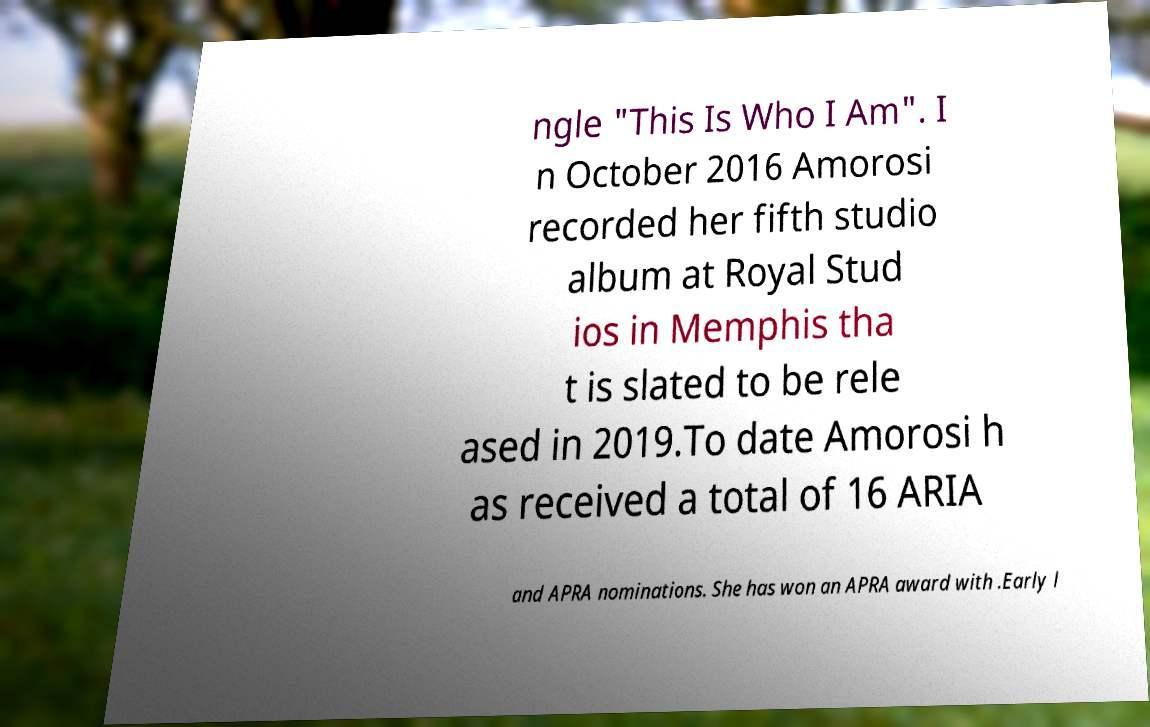There's text embedded in this image that I need extracted. Can you transcribe it verbatim? ngle "This Is Who I Am". I n October 2016 Amorosi recorded her fifth studio album at Royal Stud ios in Memphis tha t is slated to be rele ased in 2019.To date Amorosi h as received a total of 16 ARIA and APRA nominations. She has won an APRA award with .Early l 